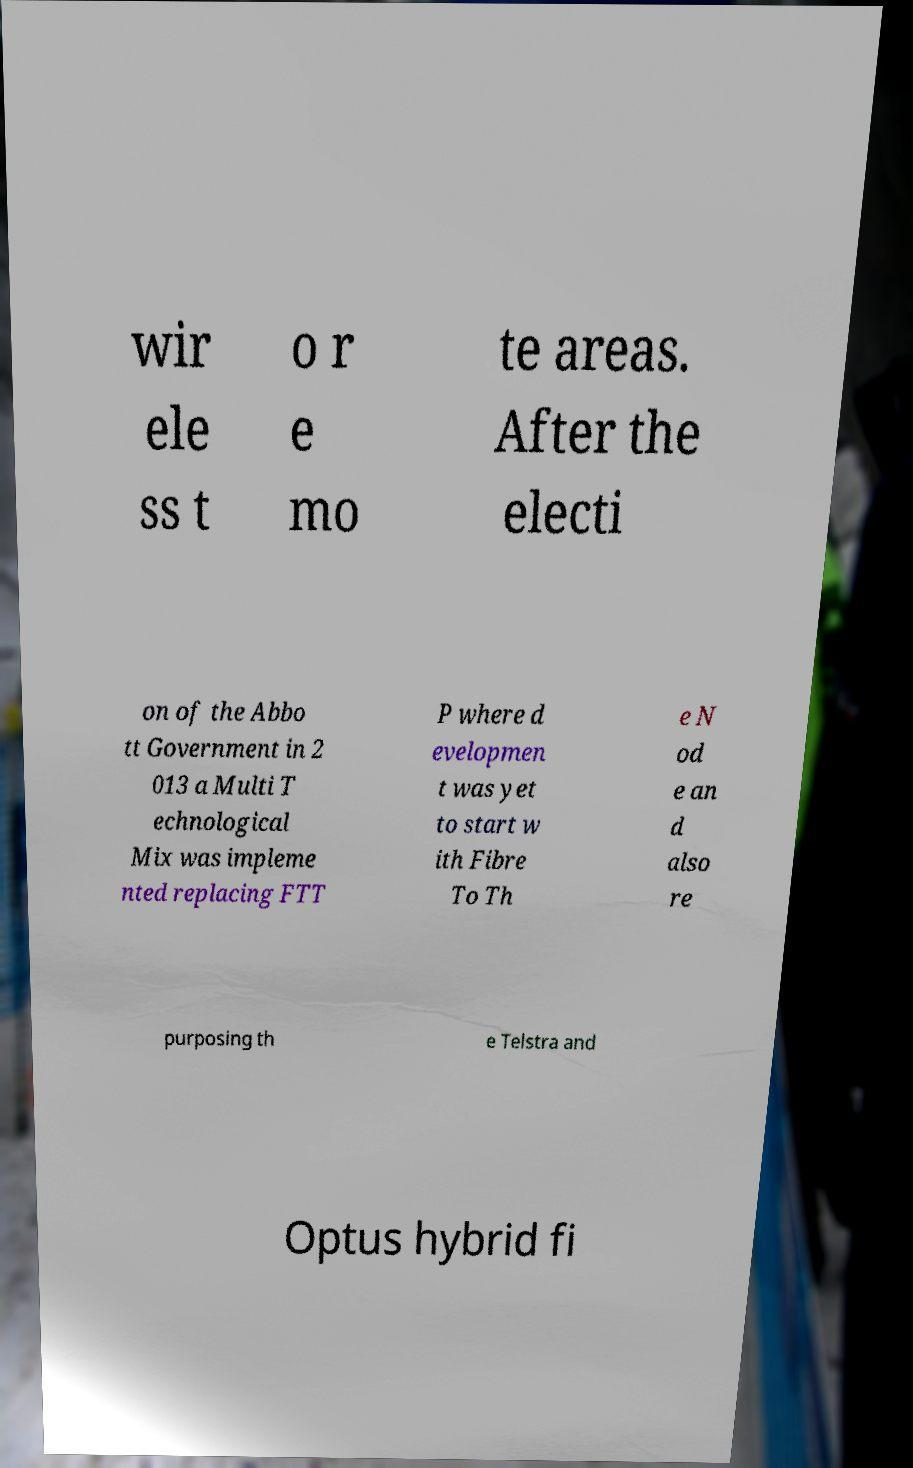Could you extract and type out the text from this image? wir ele ss t o r e mo te areas. After the electi on of the Abbo tt Government in 2 013 a Multi T echnological Mix was impleme nted replacing FTT P where d evelopmen t was yet to start w ith Fibre To Th e N od e an d also re purposing th e Telstra and Optus hybrid fi 